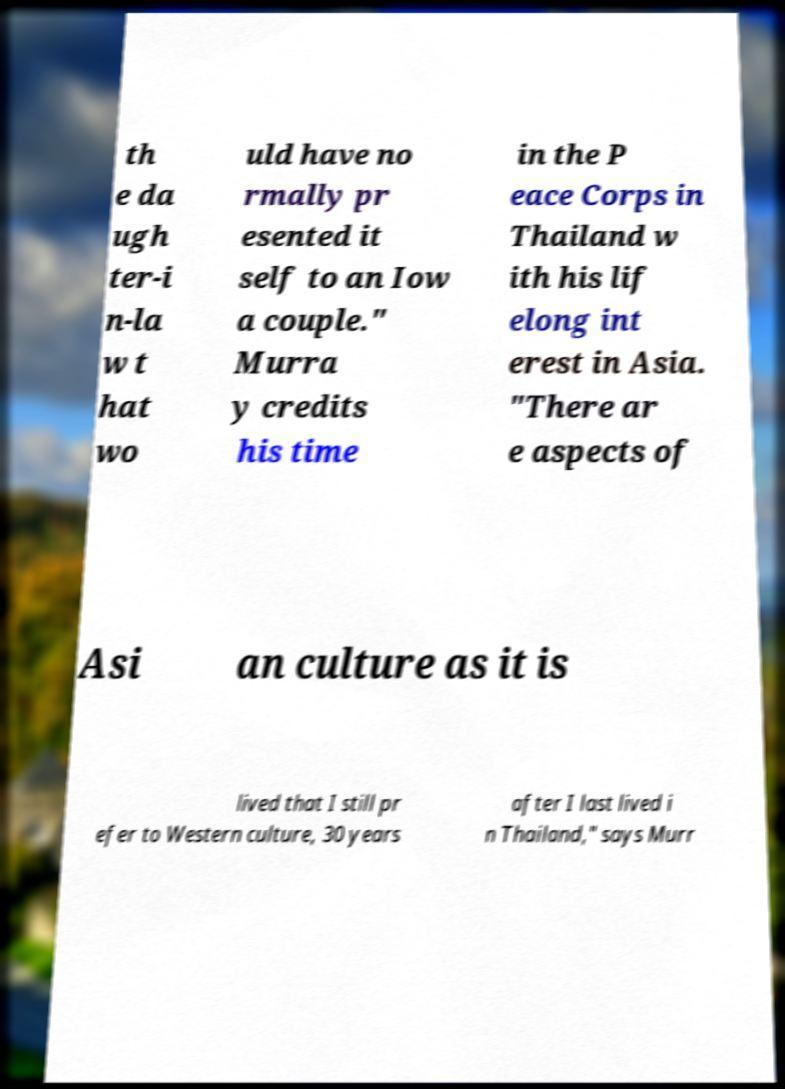Could you assist in decoding the text presented in this image and type it out clearly? th e da ugh ter-i n-la w t hat wo uld have no rmally pr esented it self to an Iow a couple." Murra y credits his time in the P eace Corps in Thailand w ith his lif elong int erest in Asia. "There ar e aspects of Asi an culture as it is lived that I still pr efer to Western culture, 30 years after I last lived i n Thailand," says Murr 